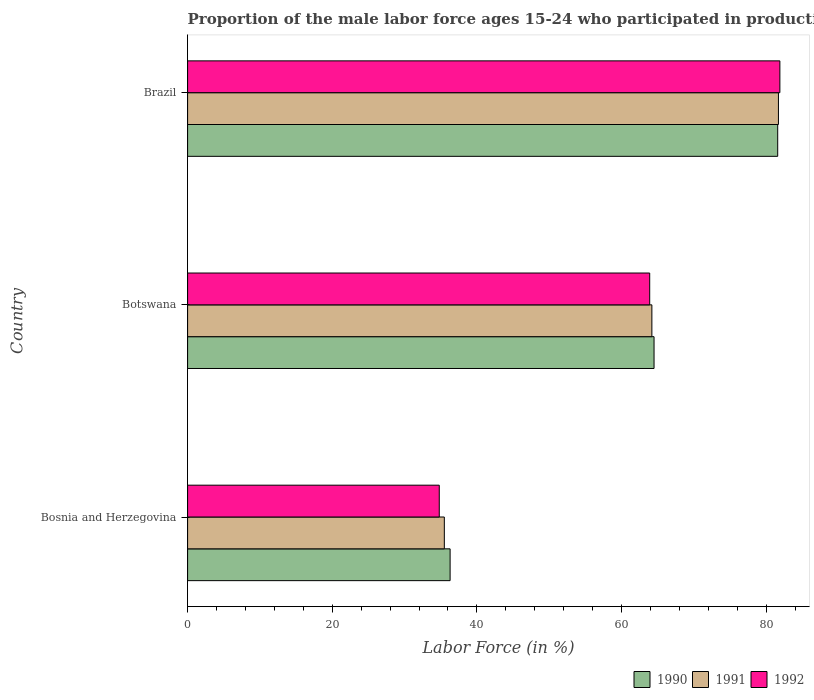How many different coloured bars are there?
Ensure brevity in your answer.  3. How many bars are there on the 2nd tick from the top?
Offer a terse response. 3. What is the label of the 2nd group of bars from the top?
Make the answer very short. Botswana. In how many cases, is the number of bars for a given country not equal to the number of legend labels?
Offer a terse response. 0. What is the proportion of the male labor force who participated in production in 1991 in Brazil?
Give a very brief answer. 81.7. Across all countries, what is the maximum proportion of the male labor force who participated in production in 1991?
Provide a succinct answer. 81.7. Across all countries, what is the minimum proportion of the male labor force who participated in production in 1991?
Offer a terse response. 35.5. In which country was the proportion of the male labor force who participated in production in 1991 minimum?
Offer a terse response. Bosnia and Herzegovina. What is the total proportion of the male labor force who participated in production in 1992 in the graph?
Offer a very short reply. 180.6. What is the difference between the proportion of the male labor force who participated in production in 1992 in Bosnia and Herzegovina and that in Botswana?
Offer a terse response. -29.1. What is the difference between the proportion of the male labor force who participated in production in 1992 in Brazil and the proportion of the male labor force who participated in production in 1991 in Botswana?
Keep it short and to the point. 17.7. What is the average proportion of the male labor force who participated in production in 1992 per country?
Your answer should be compact. 60.2. What is the difference between the proportion of the male labor force who participated in production in 1991 and proportion of the male labor force who participated in production in 1990 in Botswana?
Provide a short and direct response. -0.3. What is the ratio of the proportion of the male labor force who participated in production in 1990 in Bosnia and Herzegovina to that in Brazil?
Ensure brevity in your answer.  0.44. Is the proportion of the male labor force who participated in production in 1992 in Botswana less than that in Brazil?
Offer a terse response. Yes. Is the difference between the proportion of the male labor force who participated in production in 1991 in Botswana and Brazil greater than the difference between the proportion of the male labor force who participated in production in 1990 in Botswana and Brazil?
Ensure brevity in your answer.  No. What is the difference between the highest and the second highest proportion of the male labor force who participated in production in 1992?
Offer a very short reply. 18. What is the difference between the highest and the lowest proportion of the male labor force who participated in production in 1992?
Offer a terse response. 47.1. In how many countries, is the proportion of the male labor force who participated in production in 1990 greater than the average proportion of the male labor force who participated in production in 1990 taken over all countries?
Offer a very short reply. 2. What does the 1st bar from the top in Brazil represents?
Provide a short and direct response. 1992. How many bars are there?
Offer a terse response. 9. Are all the bars in the graph horizontal?
Offer a terse response. Yes. What is the difference between two consecutive major ticks on the X-axis?
Your answer should be very brief. 20. Are the values on the major ticks of X-axis written in scientific E-notation?
Offer a terse response. No. How many legend labels are there?
Make the answer very short. 3. How are the legend labels stacked?
Ensure brevity in your answer.  Horizontal. What is the title of the graph?
Give a very brief answer. Proportion of the male labor force ages 15-24 who participated in production. Does "2001" appear as one of the legend labels in the graph?
Provide a succinct answer. No. What is the label or title of the X-axis?
Offer a very short reply. Labor Force (in %). What is the label or title of the Y-axis?
Provide a short and direct response. Country. What is the Labor Force (in %) of 1990 in Bosnia and Herzegovina?
Your response must be concise. 36.3. What is the Labor Force (in %) of 1991 in Bosnia and Herzegovina?
Provide a short and direct response. 35.5. What is the Labor Force (in %) of 1992 in Bosnia and Herzegovina?
Your response must be concise. 34.8. What is the Labor Force (in %) of 1990 in Botswana?
Offer a very short reply. 64.5. What is the Labor Force (in %) of 1991 in Botswana?
Provide a succinct answer. 64.2. What is the Labor Force (in %) in 1992 in Botswana?
Provide a short and direct response. 63.9. What is the Labor Force (in %) of 1990 in Brazil?
Provide a succinct answer. 81.6. What is the Labor Force (in %) in 1991 in Brazil?
Offer a very short reply. 81.7. What is the Labor Force (in %) of 1992 in Brazil?
Provide a short and direct response. 81.9. Across all countries, what is the maximum Labor Force (in %) in 1990?
Your answer should be compact. 81.6. Across all countries, what is the maximum Labor Force (in %) of 1991?
Your answer should be very brief. 81.7. Across all countries, what is the maximum Labor Force (in %) of 1992?
Ensure brevity in your answer.  81.9. Across all countries, what is the minimum Labor Force (in %) in 1990?
Ensure brevity in your answer.  36.3. Across all countries, what is the minimum Labor Force (in %) in 1991?
Provide a succinct answer. 35.5. Across all countries, what is the minimum Labor Force (in %) of 1992?
Make the answer very short. 34.8. What is the total Labor Force (in %) in 1990 in the graph?
Your answer should be very brief. 182.4. What is the total Labor Force (in %) in 1991 in the graph?
Ensure brevity in your answer.  181.4. What is the total Labor Force (in %) of 1992 in the graph?
Ensure brevity in your answer.  180.6. What is the difference between the Labor Force (in %) of 1990 in Bosnia and Herzegovina and that in Botswana?
Offer a very short reply. -28.2. What is the difference between the Labor Force (in %) of 1991 in Bosnia and Herzegovina and that in Botswana?
Provide a short and direct response. -28.7. What is the difference between the Labor Force (in %) of 1992 in Bosnia and Herzegovina and that in Botswana?
Provide a succinct answer. -29.1. What is the difference between the Labor Force (in %) of 1990 in Bosnia and Herzegovina and that in Brazil?
Give a very brief answer. -45.3. What is the difference between the Labor Force (in %) in 1991 in Bosnia and Herzegovina and that in Brazil?
Your answer should be compact. -46.2. What is the difference between the Labor Force (in %) in 1992 in Bosnia and Herzegovina and that in Brazil?
Ensure brevity in your answer.  -47.1. What is the difference between the Labor Force (in %) of 1990 in Botswana and that in Brazil?
Ensure brevity in your answer.  -17.1. What is the difference between the Labor Force (in %) in 1991 in Botswana and that in Brazil?
Offer a terse response. -17.5. What is the difference between the Labor Force (in %) of 1990 in Bosnia and Herzegovina and the Labor Force (in %) of 1991 in Botswana?
Offer a very short reply. -27.9. What is the difference between the Labor Force (in %) of 1990 in Bosnia and Herzegovina and the Labor Force (in %) of 1992 in Botswana?
Make the answer very short. -27.6. What is the difference between the Labor Force (in %) of 1991 in Bosnia and Herzegovina and the Labor Force (in %) of 1992 in Botswana?
Provide a short and direct response. -28.4. What is the difference between the Labor Force (in %) of 1990 in Bosnia and Herzegovina and the Labor Force (in %) of 1991 in Brazil?
Your answer should be compact. -45.4. What is the difference between the Labor Force (in %) in 1990 in Bosnia and Herzegovina and the Labor Force (in %) in 1992 in Brazil?
Your answer should be very brief. -45.6. What is the difference between the Labor Force (in %) in 1991 in Bosnia and Herzegovina and the Labor Force (in %) in 1992 in Brazil?
Provide a short and direct response. -46.4. What is the difference between the Labor Force (in %) in 1990 in Botswana and the Labor Force (in %) in 1991 in Brazil?
Make the answer very short. -17.2. What is the difference between the Labor Force (in %) in 1990 in Botswana and the Labor Force (in %) in 1992 in Brazil?
Your answer should be very brief. -17.4. What is the difference between the Labor Force (in %) in 1991 in Botswana and the Labor Force (in %) in 1992 in Brazil?
Your response must be concise. -17.7. What is the average Labor Force (in %) of 1990 per country?
Your response must be concise. 60.8. What is the average Labor Force (in %) in 1991 per country?
Your answer should be very brief. 60.47. What is the average Labor Force (in %) of 1992 per country?
Your response must be concise. 60.2. What is the difference between the Labor Force (in %) of 1990 and Labor Force (in %) of 1991 in Bosnia and Herzegovina?
Keep it short and to the point. 0.8. What is the difference between the Labor Force (in %) of 1990 and Labor Force (in %) of 1992 in Bosnia and Herzegovina?
Offer a terse response. 1.5. What is the difference between the Labor Force (in %) in 1990 and Labor Force (in %) in 1991 in Botswana?
Ensure brevity in your answer.  0.3. What is the difference between the Labor Force (in %) in 1990 and Labor Force (in %) in 1992 in Botswana?
Provide a succinct answer. 0.6. What is the difference between the Labor Force (in %) of 1990 and Labor Force (in %) of 1992 in Brazil?
Provide a short and direct response. -0.3. What is the difference between the Labor Force (in %) of 1991 and Labor Force (in %) of 1992 in Brazil?
Give a very brief answer. -0.2. What is the ratio of the Labor Force (in %) in 1990 in Bosnia and Herzegovina to that in Botswana?
Provide a succinct answer. 0.56. What is the ratio of the Labor Force (in %) of 1991 in Bosnia and Herzegovina to that in Botswana?
Your answer should be very brief. 0.55. What is the ratio of the Labor Force (in %) of 1992 in Bosnia and Herzegovina to that in Botswana?
Your answer should be compact. 0.54. What is the ratio of the Labor Force (in %) in 1990 in Bosnia and Herzegovina to that in Brazil?
Make the answer very short. 0.44. What is the ratio of the Labor Force (in %) in 1991 in Bosnia and Herzegovina to that in Brazil?
Offer a terse response. 0.43. What is the ratio of the Labor Force (in %) of 1992 in Bosnia and Herzegovina to that in Brazil?
Provide a succinct answer. 0.42. What is the ratio of the Labor Force (in %) of 1990 in Botswana to that in Brazil?
Provide a succinct answer. 0.79. What is the ratio of the Labor Force (in %) in 1991 in Botswana to that in Brazil?
Offer a very short reply. 0.79. What is the ratio of the Labor Force (in %) of 1992 in Botswana to that in Brazil?
Your response must be concise. 0.78. What is the difference between the highest and the second highest Labor Force (in %) in 1990?
Make the answer very short. 17.1. What is the difference between the highest and the second highest Labor Force (in %) of 1991?
Provide a succinct answer. 17.5. What is the difference between the highest and the lowest Labor Force (in %) of 1990?
Make the answer very short. 45.3. What is the difference between the highest and the lowest Labor Force (in %) of 1991?
Offer a very short reply. 46.2. What is the difference between the highest and the lowest Labor Force (in %) of 1992?
Your response must be concise. 47.1. 